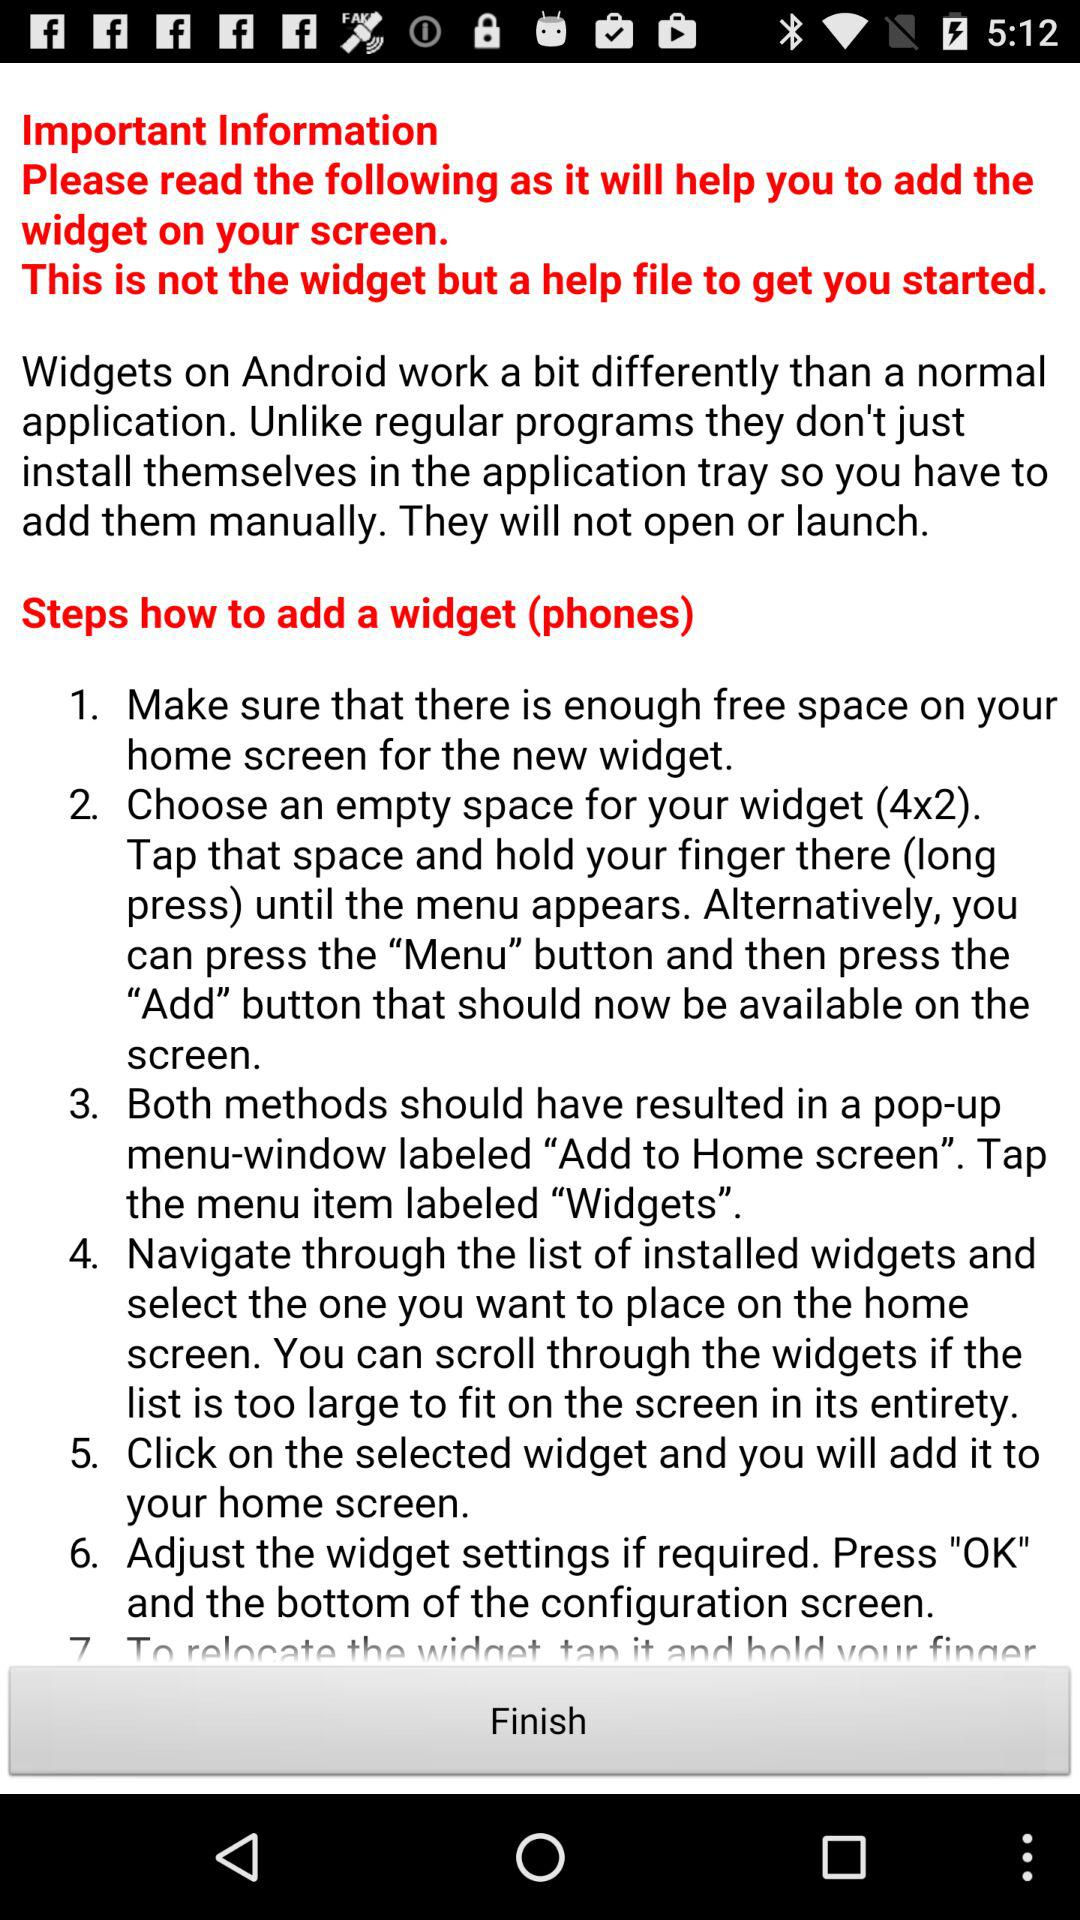What are the steps to adding a widget? The steps are "Make sure that there is enough free space on your home screen for the new widget.", "Choose an empty space for your widget (4x2). Tap that space and hold your finger there (long press) until the menu appears. Alternatively, you can press the "Menu" button and then press the "Add" button that should now be available on the screen.", "Both methods should have resulted in a pop-up menu-window labeled "Add to Home screen". Tap the menu item labeled "Widgets".", "Navigate through the list of installed widgets and select the one you want to place on the home screen. You can scroll through the widgets if the list is too large to fit on the screen in its entirety.", "Click on the selected widget and you will add it to your home screen.", and "Adjust the widget settings if required. Press "OK" and the bottom of the configuration screen.". 